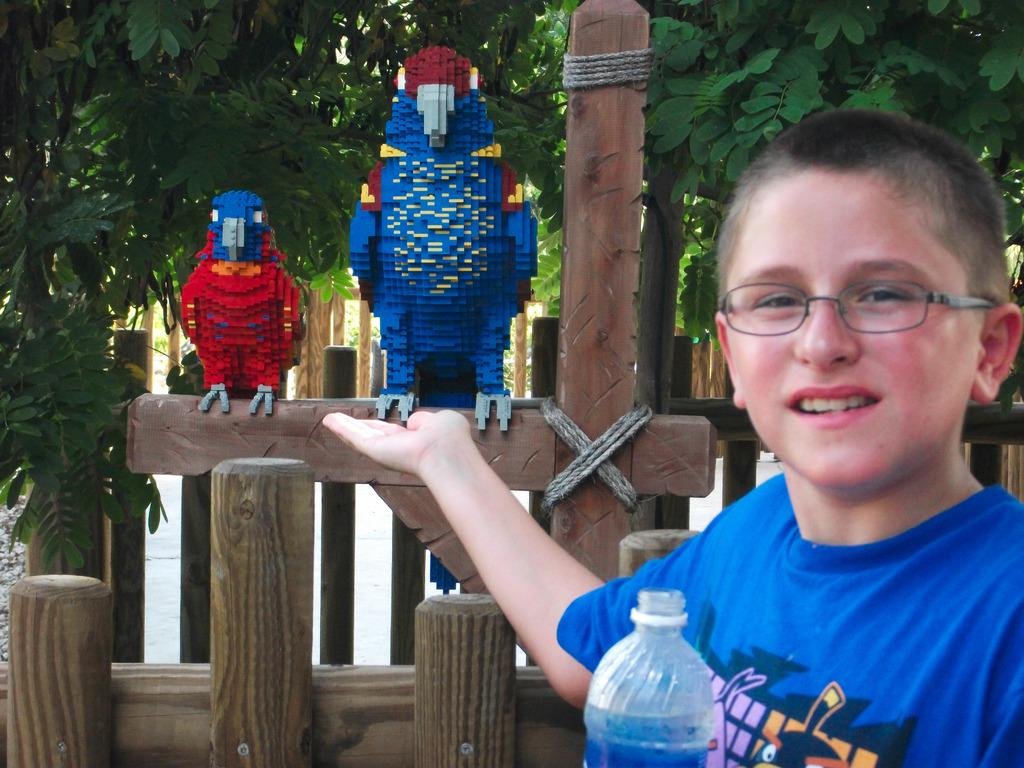Who is the main subject in the picture? There is a boy in the picture. What is the boy holding in the picture? The boy is holding a bottle. What type of natural environment can be seen in the picture? There are trees visible in the picture. What type of decorative objects are present in the picture? There are artificial birds on a wooden pole in the picture. What type of knot is tied on the stick in the picture? There is no stick or knot present in the picture. 